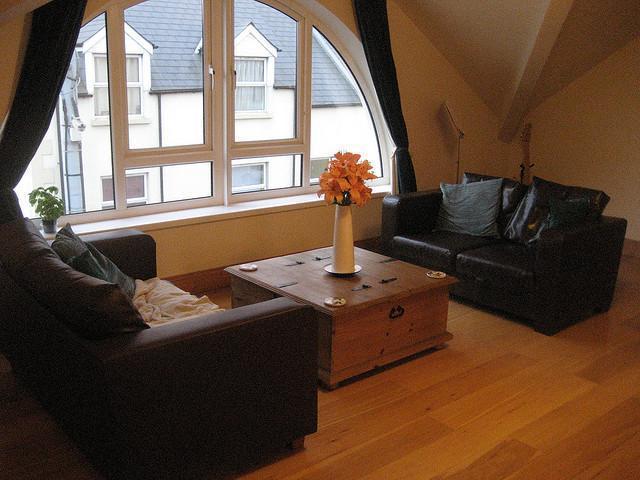How many couches are there?
Give a very brief answer. 3. 